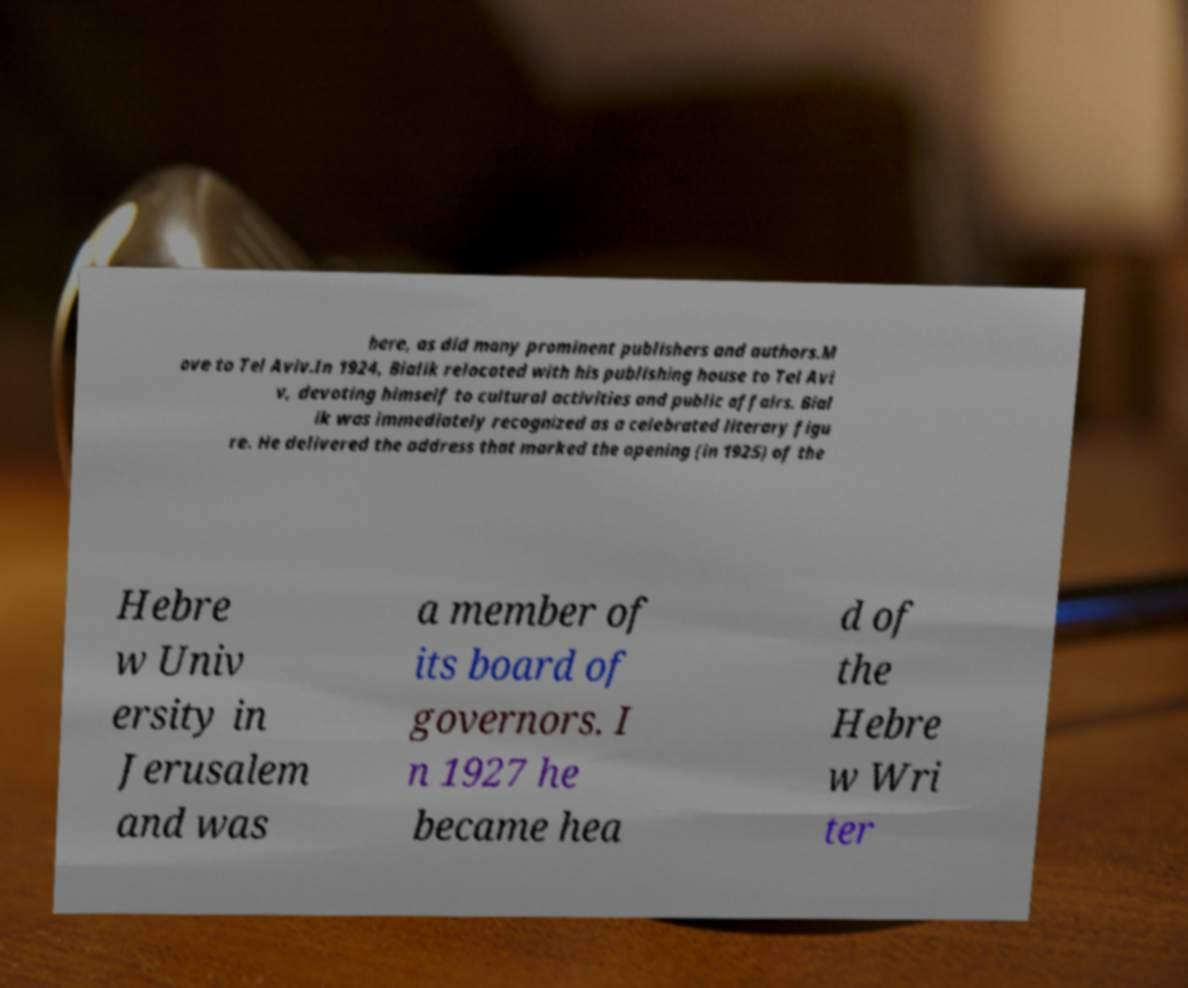Please identify and transcribe the text found in this image. here, as did many prominent publishers and authors.M ove to Tel Aviv.In 1924, Bialik relocated with his publishing house to Tel Avi v, devoting himself to cultural activities and public affairs. Bial ik was immediately recognized as a celebrated literary figu re. He delivered the address that marked the opening (in 1925) of the Hebre w Univ ersity in Jerusalem and was a member of its board of governors. I n 1927 he became hea d of the Hebre w Wri ter 